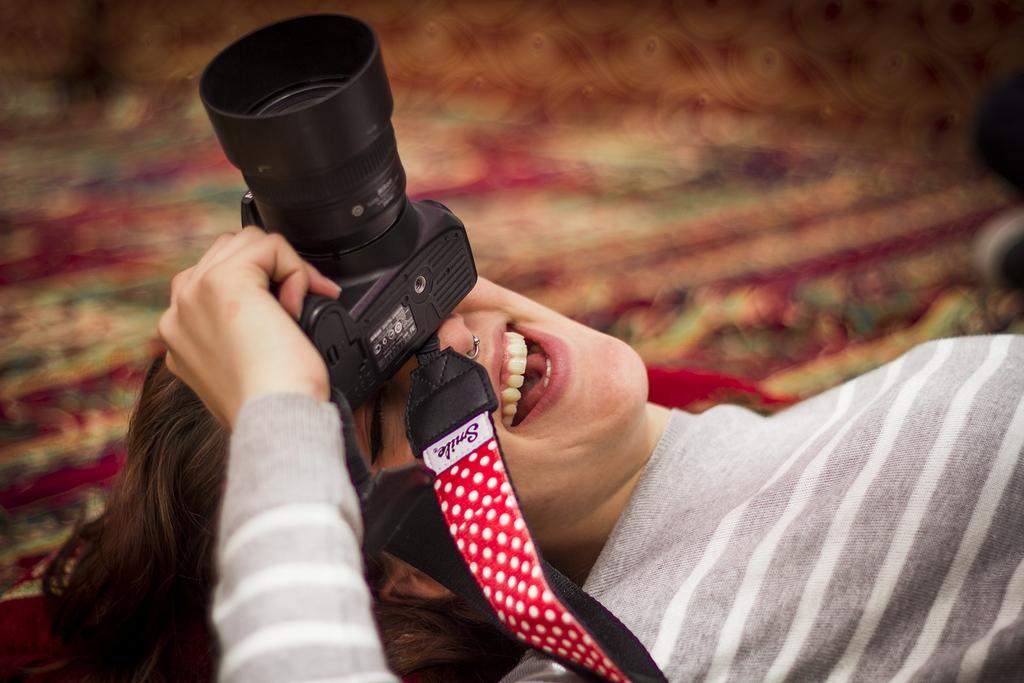Describe this image in one or two sentences. In this image I can see a girl lying on the floor holding a camera. 